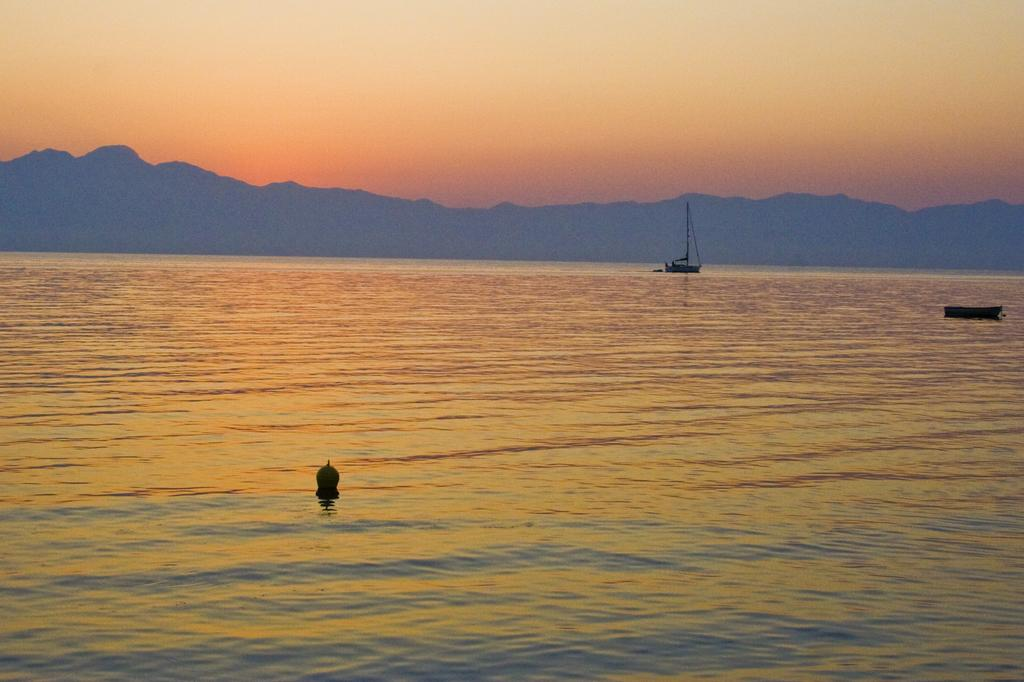What is the main setting of the image? The image depicts a sea. Are there any objects or vehicles in the sea? Yes, there is a small boat and a ship in the sea. What can be seen in the background of the image? There are mountains visible in the background. What type of record is being played on the ship in the image? There is no record or music player visible in the image, so it cannot be determined if a record is being played on the ship. 